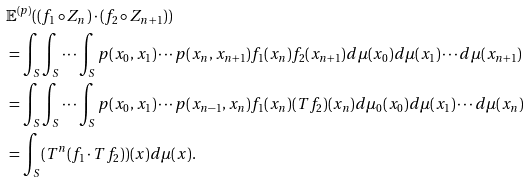<formula> <loc_0><loc_0><loc_500><loc_500>& \mathbb { E } ^ { ( p ) } ( ( f _ { 1 } \circ Z _ { n } ) \cdot ( f _ { 2 } \circ Z _ { n + 1 } ) ) \\ & = \int _ { S } \int _ { S } \cdots \int _ { S } p ( x _ { 0 } , x _ { 1 } ) \cdots p ( x _ { n } , x _ { n + 1 } ) f _ { 1 } ( x _ { n } ) f _ { 2 } ( x _ { n + 1 } ) d \mu ( x _ { 0 } ) d \mu ( x _ { 1 } ) \cdots d \mu ( x _ { n + 1 } ) \\ & = \int _ { S } \int _ { S } \cdots \int _ { S } p ( x _ { 0 } , x _ { 1 } ) \cdots p ( x _ { n - 1 } , x _ { n } ) f _ { 1 } ( x _ { n } ) ( T f _ { 2 } ) ( x _ { n } ) d \mu _ { 0 } ( x _ { 0 } ) d \mu ( x _ { 1 } ) \cdots d \mu ( x _ { n } ) \\ & = \int _ { S } ( T ^ { n } ( f _ { 1 } \cdot T f _ { 2 } ) ) ( x ) d \mu ( x ) .</formula> 